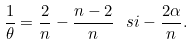<formula> <loc_0><loc_0><loc_500><loc_500>\frac { 1 } { \theta } = \frac { 2 } { n } - \frac { n - 2 } { n } \ s i - \frac { 2 \alpha } { n } .</formula> 